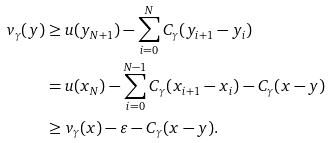<formula> <loc_0><loc_0><loc_500><loc_500>v _ { \gamma } ( y ) & \geq u ( y _ { N + 1 } ) - \sum _ { i = 0 } ^ { N } C _ { \gamma } ( y _ { i + 1 } - y _ { i } ) \\ & = u ( x _ { N } ) - \sum _ { i = 0 } ^ { N - 1 } C _ { \gamma } ( x _ { i + 1 } - x _ { i } ) - C _ { \gamma } ( x - y ) \\ & \geq v _ { \gamma } ( x ) - \varepsilon - C _ { \gamma } ( x - y ) .</formula> 